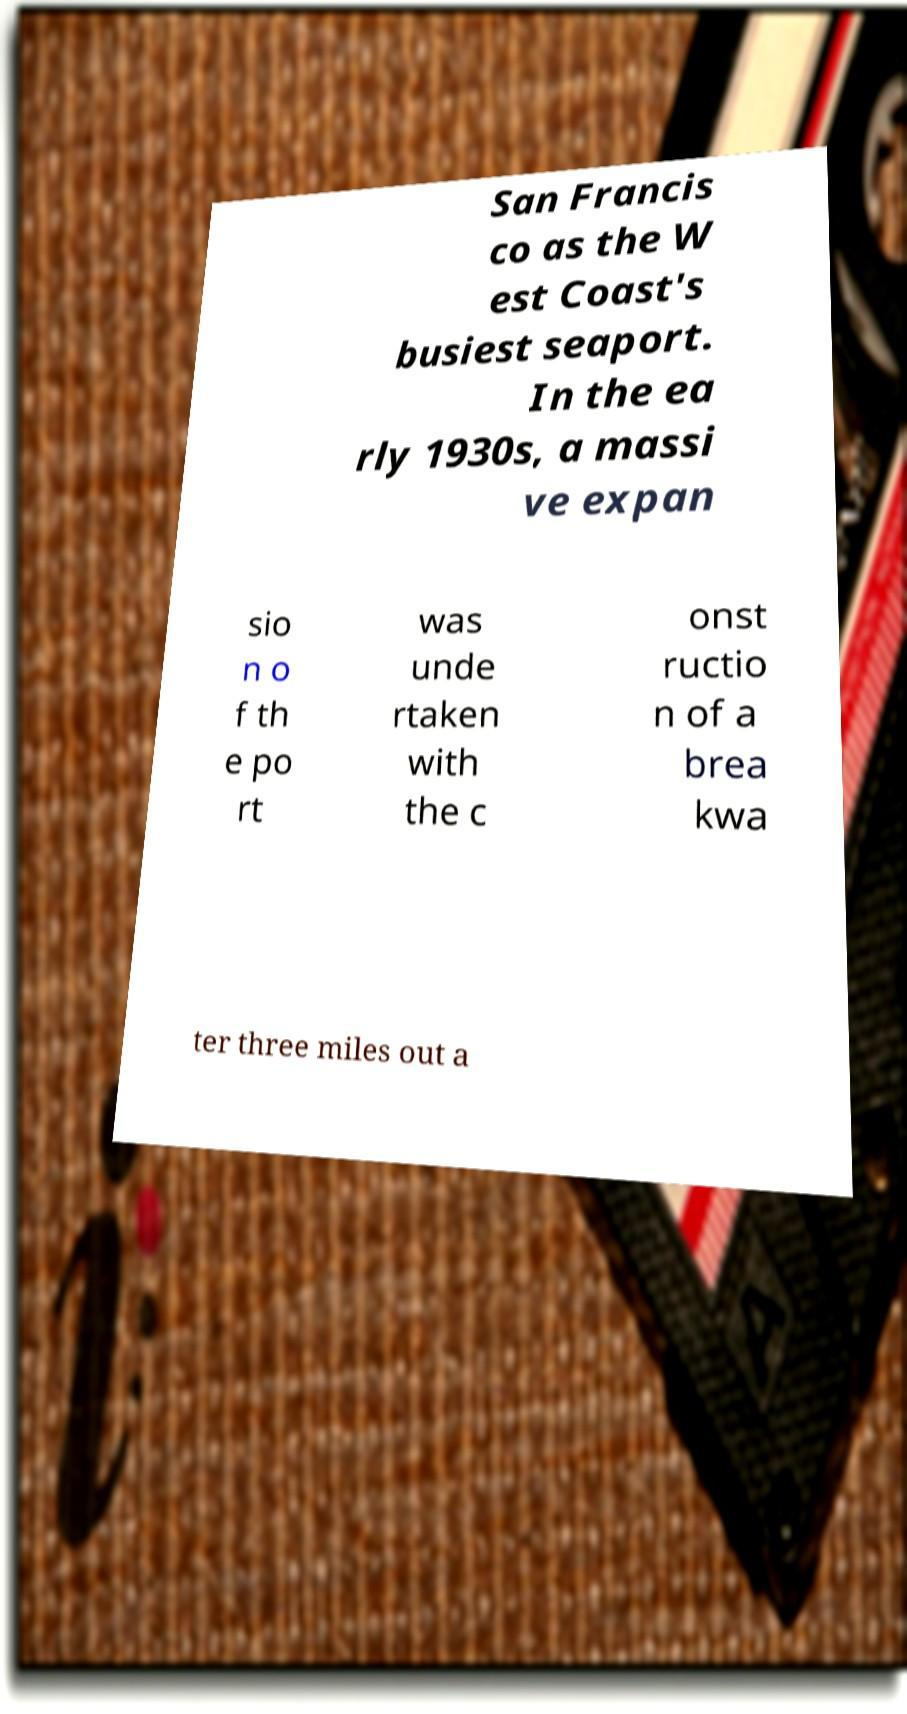Can you accurately transcribe the text from the provided image for me? San Francis co as the W est Coast's busiest seaport. In the ea rly 1930s, a massi ve expan sio n o f th e po rt was unde rtaken with the c onst ructio n of a brea kwa ter three miles out a 